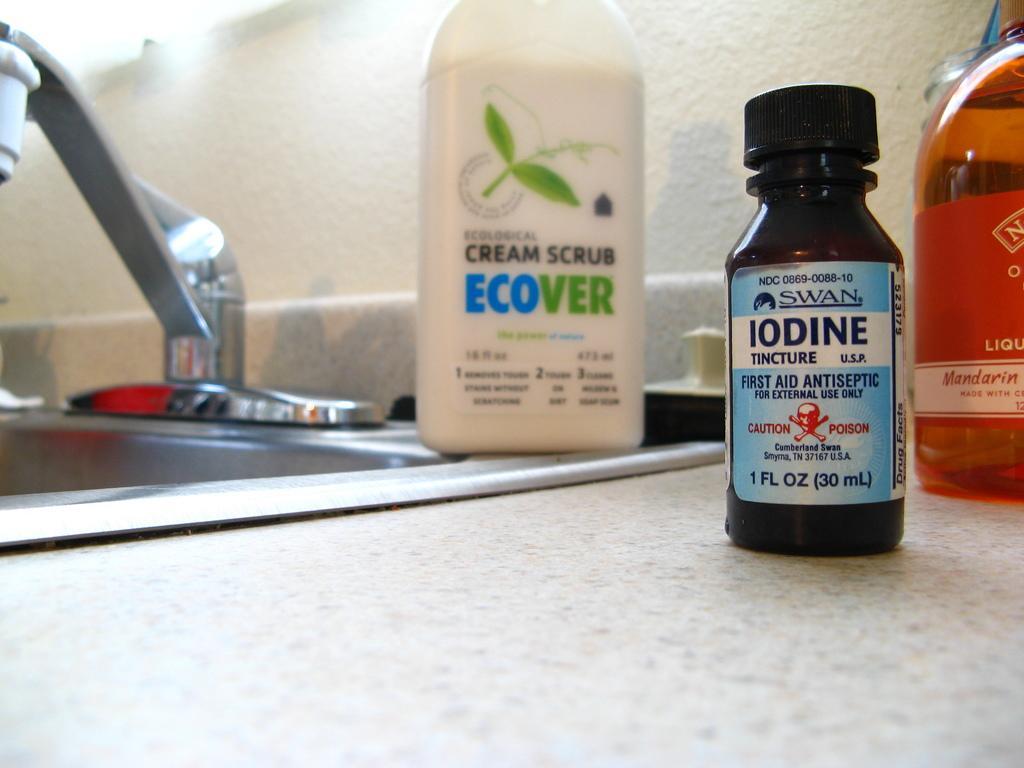Can you describe this image briefly? Here we can see a antiseptic bottle and there are other two bottles present and beside that we can see a sink 